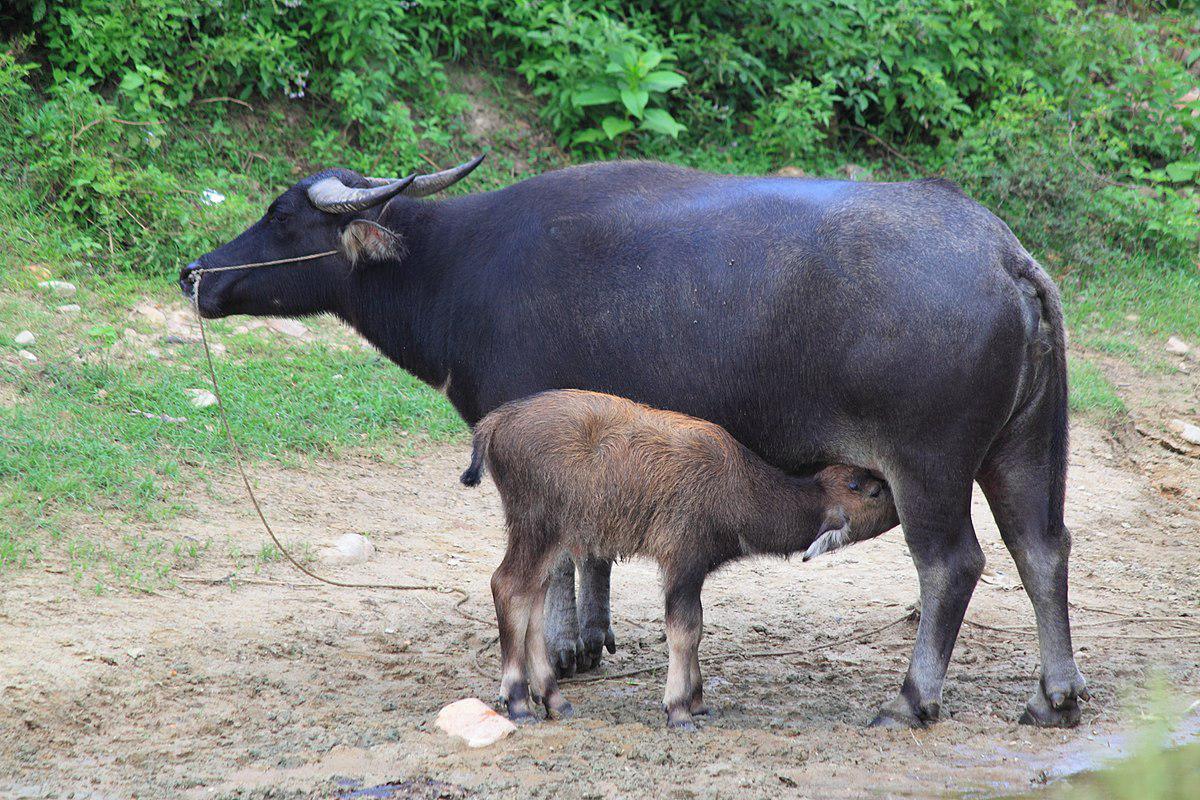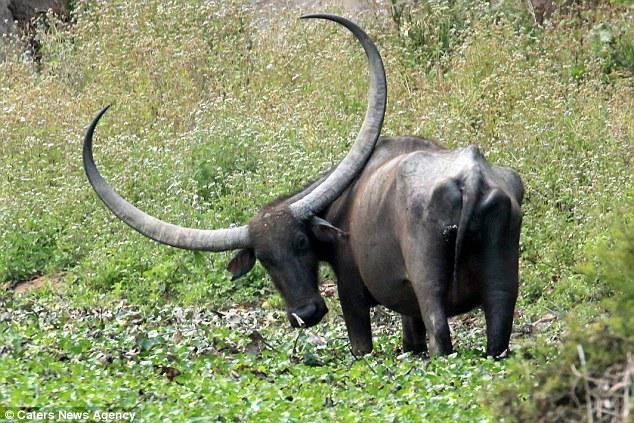The first image is the image on the left, the second image is the image on the right. Analyze the images presented: Is the assertion "A calf has its head and neck bent under a standing adult horned animal to nurse." valid? Answer yes or no. Yes. The first image is the image on the left, the second image is the image on the right. Analyze the images presented: Is the assertion "There are three water buffalo's." valid? Answer yes or no. Yes. 